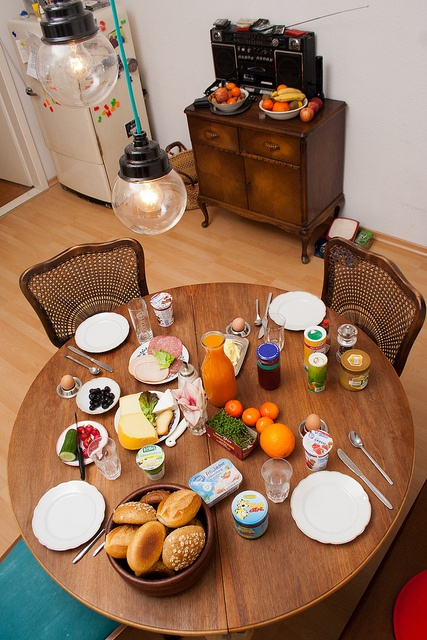Describe the objects in this image and their specific colors. I can see dining table in darkgray, brown, lightgray, salmon, and maroon tones, refrigerator in darkgray, tan, and gray tones, bowl in darkgray, black, orange, maroon, and brown tones, chair in darkgray, maroon, black, and brown tones, and chair in darkgray, maroon, black, and brown tones in this image. 